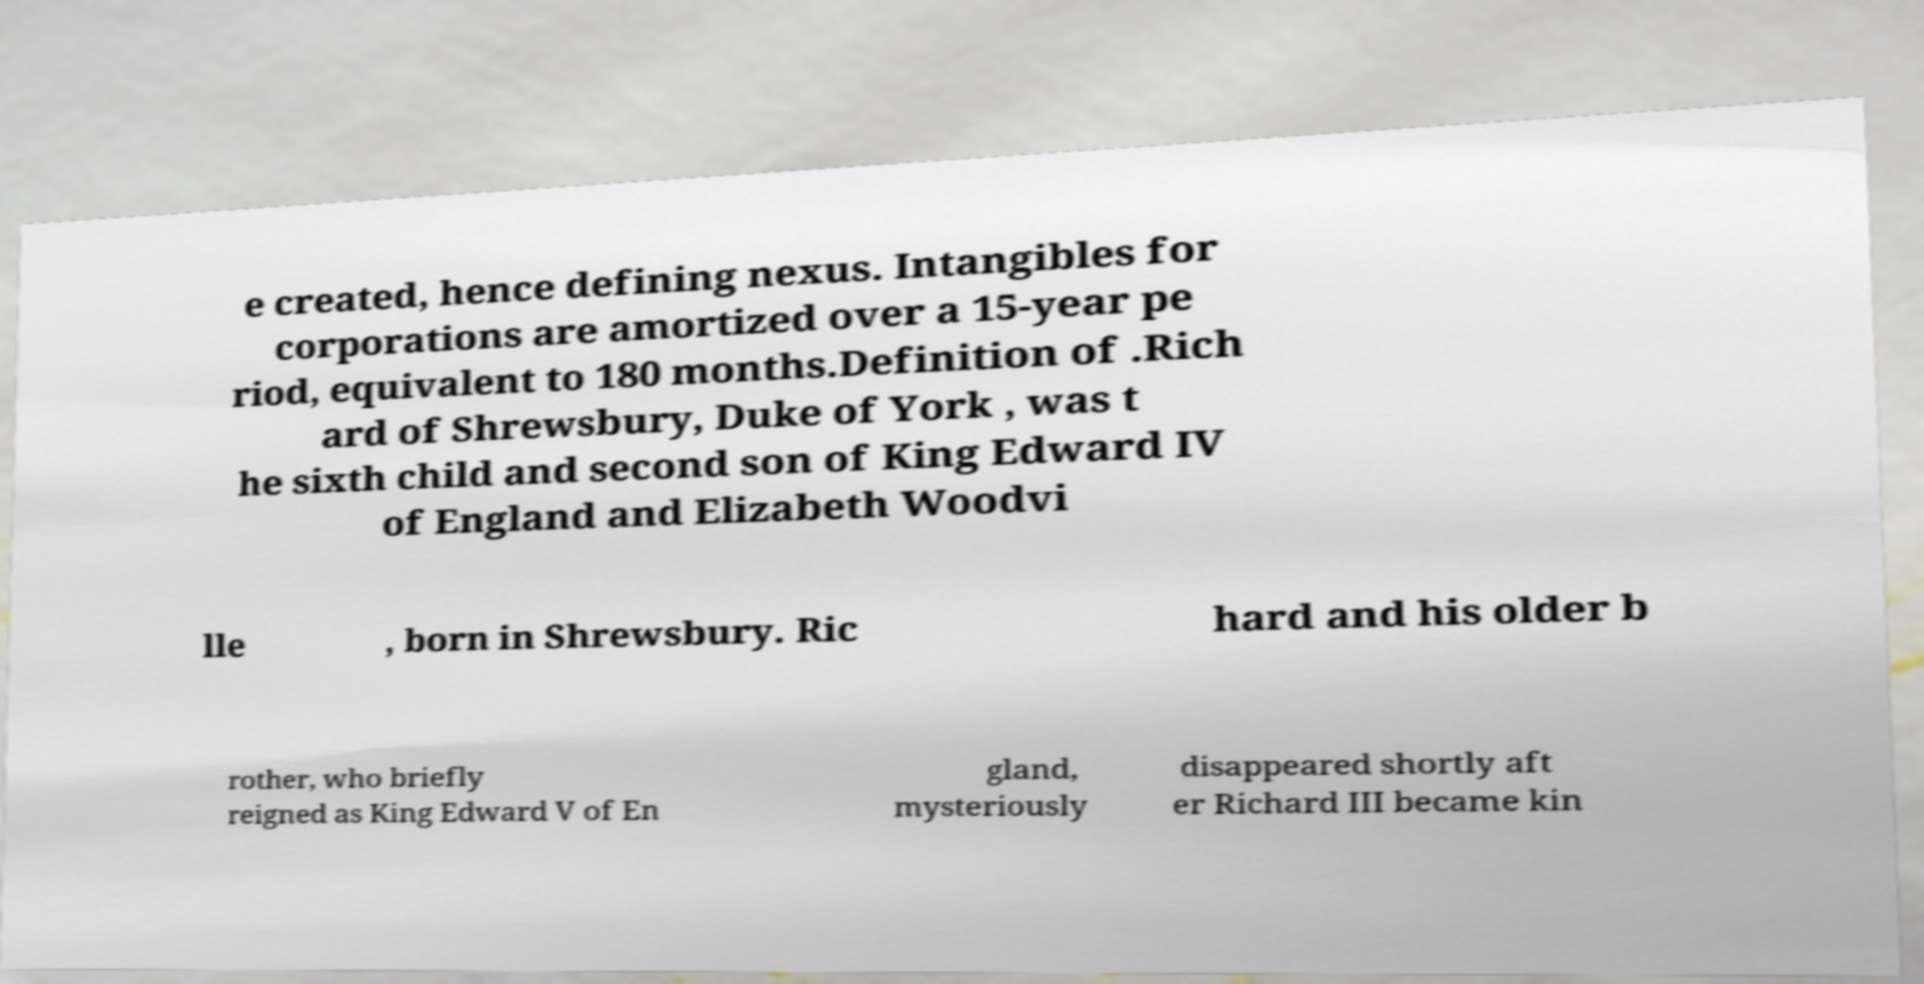There's text embedded in this image that I need extracted. Can you transcribe it verbatim? e created, hence defining nexus. Intangibles for corporations are amortized over a 15-year pe riod, equivalent to 180 months.Definition of .Rich ard of Shrewsbury, Duke of York , was t he sixth child and second son of King Edward IV of England and Elizabeth Woodvi lle , born in Shrewsbury. Ric hard and his older b rother, who briefly reigned as King Edward V of En gland, mysteriously disappeared shortly aft er Richard III became kin 